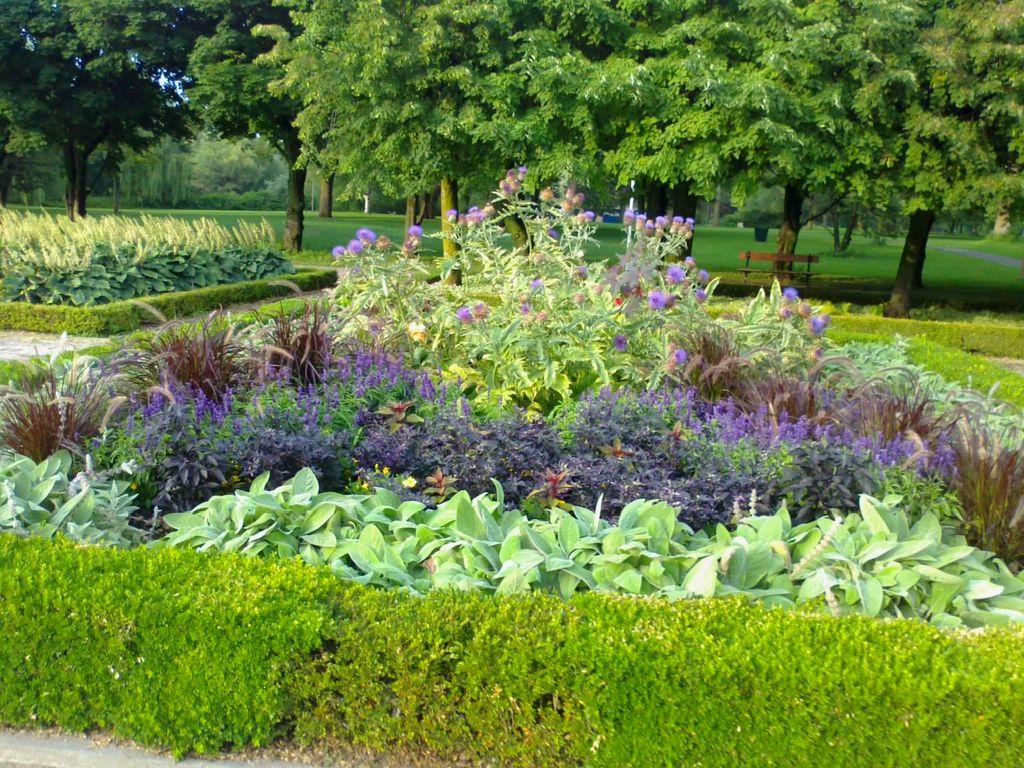What types of vegetation are at the bottom of the image? There are plants and flowers at the bottom of the image. What can be seen in the background of the image? There are trees, grass, and a bench in the background of the image. Are there any planes flying in the sky in the image? There is no mention of planes or a sky in the image, so it cannot be determined if there are any planes flying. Can you see any screws holding the bench together in the image? There is no indication of screws or any visible fasteners holding the bench together in the image. 